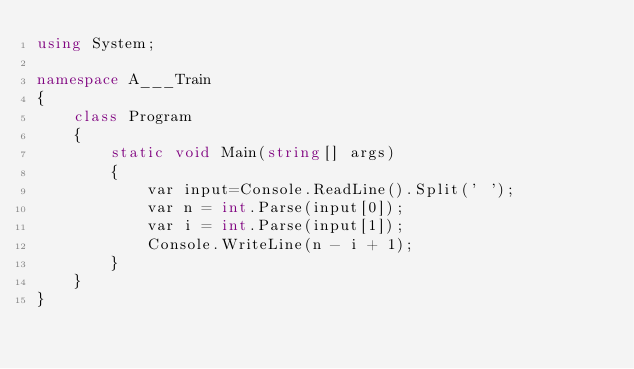<code> <loc_0><loc_0><loc_500><loc_500><_C#_>using System;

namespace A___Train
{
    class Program
    {
        static void Main(string[] args)
        {
            var input=Console.ReadLine().Split(' ');
            var n = int.Parse(input[0]);
            var i = int.Parse(input[1]);
            Console.WriteLine(n - i + 1);
        }
    }
}</code> 